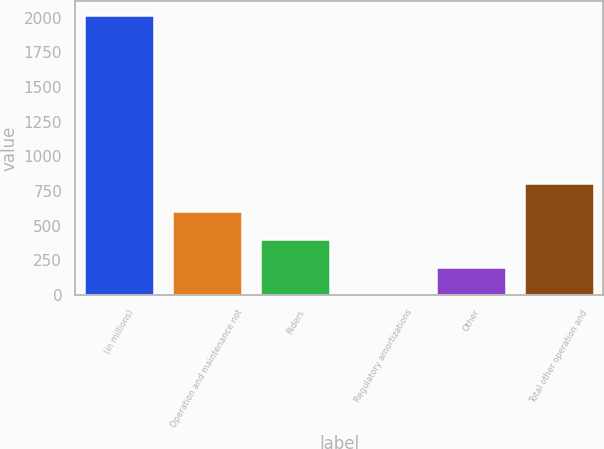Convert chart. <chart><loc_0><loc_0><loc_500><loc_500><bar_chart><fcel>(in millions)<fcel>Operation and maintenance not<fcel>Riders<fcel>Regulatory amortizations<fcel>Other<fcel>Total other operation and<nl><fcel>2017<fcel>605.8<fcel>404.2<fcel>1<fcel>202.6<fcel>807.4<nl></chart> 